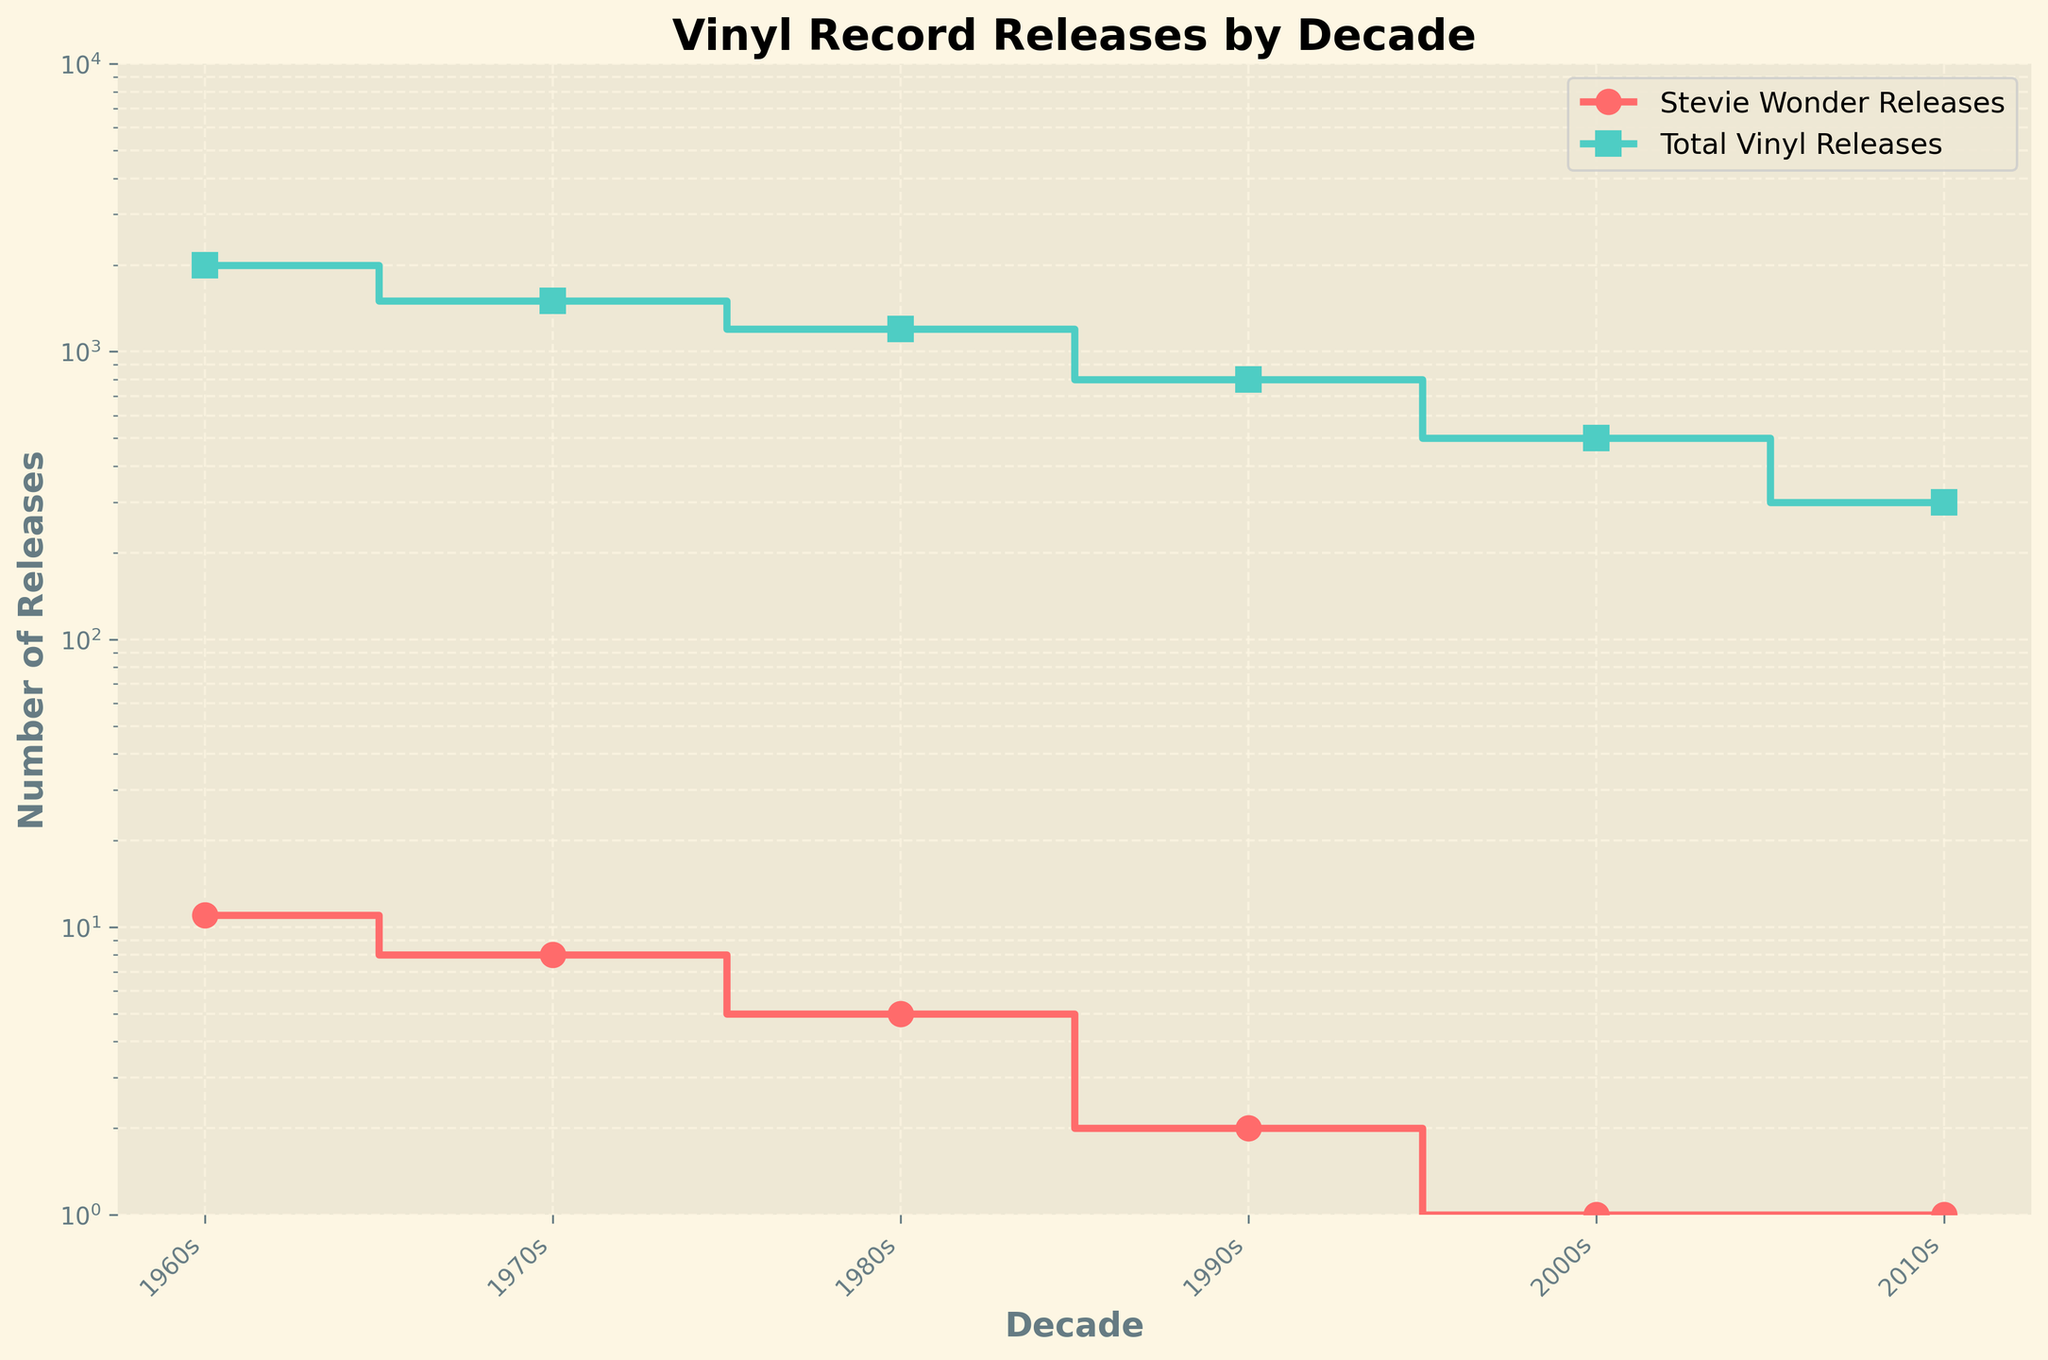What's the title of the figure? The title of the figure is displayed at the top in bold text.
Answer: Vinyl Record Releases by Decade What decades are shown on the x-axis? The x-axis has tick labels showing specific decades.
Answer: 1960s, 1970s, 1980s, 1990s, 2000s, 2010s Which decade had the highest total vinyl releases? Look at the curve labeled 'Total Vinyl Releases' and identify its highest point.
Answer: 1960s How many releases did Stevie Wonder have in the 1970s? Find the marker on the 'Stevie Wonder Releases' line corresponding to the 1970s on the x-axis.
Answer: 8 In which decade did total vinyl releases decrease the most compared to the previous decade? Observe the largest drop in the 'Total Vinyl Releases' line between consecutive decades.
Answer: 1970s to 1980s By how much did total vinyl releases change from the 1990s to the 2000s? Subtract the total vinyl releases in the 2000s from that of the 1990s.
Answer: 300 Did Stevie Wonder release more albums in the 1960s or the 1980s? Compare the data points for Stevie Wonder releases in both decades.
Answer: 1960s How many total data points are plotted on the figure? Count the markers for both lines (one for Stevie Wonder releases and one for total vinyl releases) across all decades.
Answer: 12 Which decade showed the least number of vinyl releases for Stevie Wonder? Identify the decade with the lowest marker on the 'Stevie Wonder Releases' line.
Answer: 2000s or 2010s (both have 1 release) What is the trend in Stevie Wonder's releases from the 1960s to the 2010s? Observe the general direction of the 'Stevie Wonder Releases' line over time.
Answer: Downward trend 